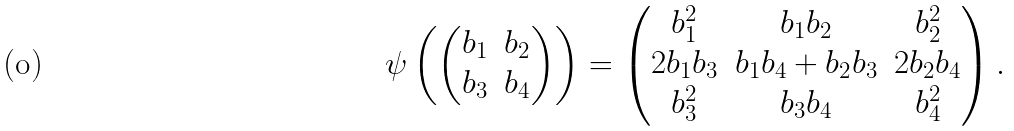Convert formula to latex. <formula><loc_0><loc_0><loc_500><loc_500>\psi \left ( \begin{pmatrix} b _ { 1 } & b _ { 2 } \\ b _ { 3 } & b _ { 4 } \end{pmatrix} \right ) = \begin{pmatrix} b _ { 1 } ^ { 2 } & b _ { 1 } b _ { 2 } & b _ { 2 } ^ { 2 } \\ 2 b _ { 1 } b _ { 3 } & b _ { 1 } b _ { 4 } + b _ { 2 } b _ { 3 } & 2 b _ { 2 } b _ { 4 } \\ b _ { 3 } ^ { 2 } & b _ { 3 } b _ { 4 } & b _ { 4 } ^ { 2 } \end{pmatrix} .</formula> 